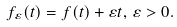Convert formula to latex. <formula><loc_0><loc_0><loc_500><loc_500>f _ { \varepsilon } ( t ) = f ( t ) + \varepsilon t , \, \varepsilon > 0 .</formula> 